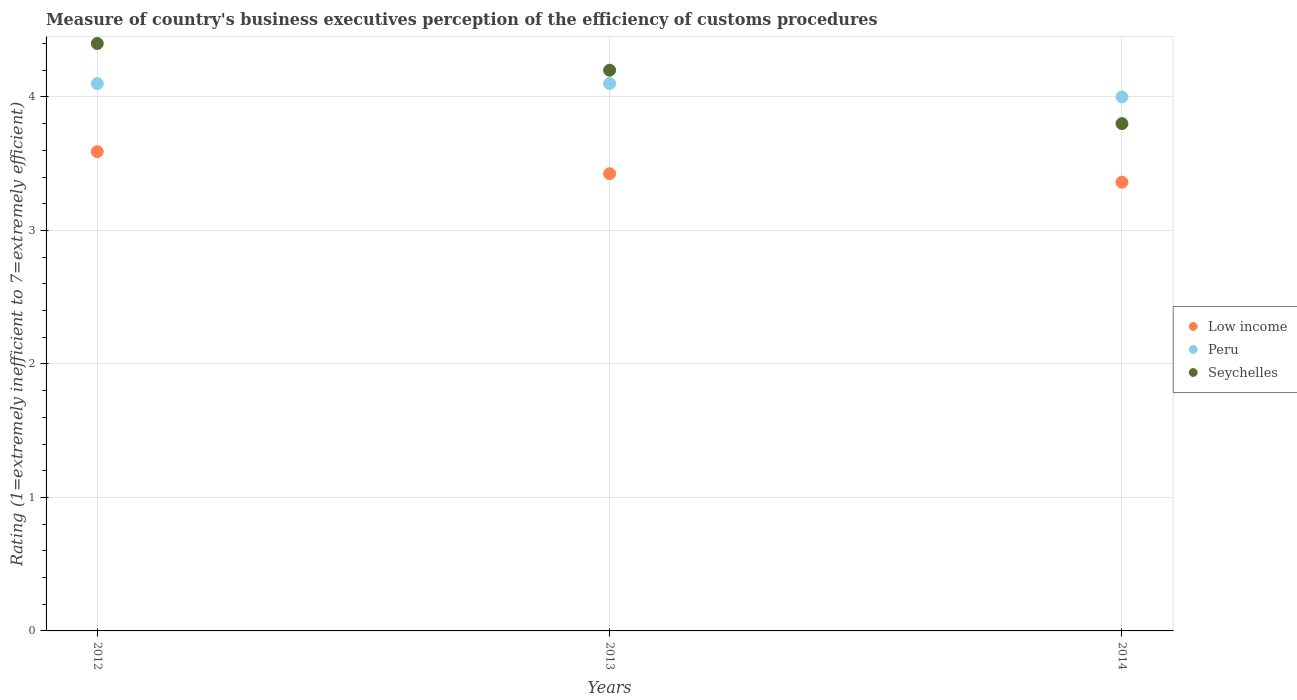How many different coloured dotlines are there?
Offer a very short reply. 3. What is the rating of the efficiency of customs procedure in Peru in 2014?
Your answer should be compact. 4. Across all years, what is the maximum rating of the efficiency of customs procedure in Low income?
Keep it short and to the point. 3.59. Across all years, what is the minimum rating of the efficiency of customs procedure in Low income?
Provide a succinct answer. 3.36. In which year was the rating of the efficiency of customs procedure in Peru maximum?
Offer a very short reply. 2012. In which year was the rating of the efficiency of customs procedure in Seychelles minimum?
Offer a terse response. 2014. What is the total rating of the efficiency of customs procedure in Low income in the graph?
Keep it short and to the point. 10.38. What is the difference between the rating of the efficiency of customs procedure in Seychelles in 2013 and that in 2014?
Your answer should be very brief. 0.4. What is the difference between the rating of the efficiency of customs procedure in Peru in 2013 and the rating of the efficiency of customs procedure in Low income in 2014?
Keep it short and to the point. 0.74. What is the average rating of the efficiency of customs procedure in Peru per year?
Your answer should be compact. 4.07. In the year 2012, what is the difference between the rating of the efficiency of customs procedure in Peru and rating of the efficiency of customs procedure in Seychelles?
Keep it short and to the point. -0.3. What is the ratio of the rating of the efficiency of customs procedure in Low income in 2012 to that in 2013?
Make the answer very short. 1.05. Is the difference between the rating of the efficiency of customs procedure in Peru in 2013 and 2014 greater than the difference between the rating of the efficiency of customs procedure in Seychelles in 2013 and 2014?
Provide a succinct answer. No. What is the difference between the highest and the second highest rating of the efficiency of customs procedure in Low income?
Offer a very short reply. 0.17. What is the difference between the highest and the lowest rating of the efficiency of customs procedure in Seychelles?
Your response must be concise. 0.6. Is the sum of the rating of the efficiency of customs procedure in Seychelles in 2013 and 2014 greater than the maximum rating of the efficiency of customs procedure in Peru across all years?
Provide a short and direct response. Yes. Is it the case that in every year, the sum of the rating of the efficiency of customs procedure in Peru and rating of the efficiency of customs procedure in Seychelles  is greater than the rating of the efficiency of customs procedure in Low income?
Provide a succinct answer. Yes. Are the values on the major ticks of Y-axis written in scientific E-notation?
Your response must be concise. No. Does the graph contain any zero values?
Offer a terse response. No. Where does the legend appear in the graph?
Offer a terse response. Center right. How are the legend labels stacked?
Provide a short and direct response. Vertical. What is the title of the graph?
Your answer should be compact. Measure of country's business executives perception of the efficiency of customs procedures. Does "Benin" appear as one of the legend labels in the graph?
Provide a short and direct response. No. What is the label or title of the Y-axis?
Your answer should be very brief. Rating (1=extremely inefficient to 7=extremely efficient). What is the Rating (1=extremely inefficient to 7=extremely efficient) in Low income in 2012?
Your response must be concise. 3.59. What is the Rating (1=extremely inefficient to 7=extremely efficient) in Low income in 2013?
Your response must be concise. 3.42. What is the Rating (1=extremely inefficient to 7=extremely efficient) of Seychelles in 2013?
Keep it short and to the point. 4.2. What is the Rating (1=extremely inefficient to 7=extremely efficient) of Low income in 2014?
Offer a very short reply. 3.36. What is the Rating (1=extremely inefficient to 7=extremely efficient) in Seychelles in 2014?
Give a very brief answer. 3.8. Across all years, what is the maximum Rating (1=extremely inefficient to 7=extremely efficient) in Low income?
Your response must be concise. 3.59. Across all years, what is the minimum Rating (1=extremely inefficient to 7=extremely efficient) in Low income?
Ensure brevity in your answer.  3.36. Across all years, what is the minimum Rating (1=extremely inefficient to 7=extremely efficient) in Seychelles?
Ensure brevity in your answer.  3.8. What is the total Rating (1=extremely inefficient to 7=extremely efficient) of Low income in the graph?
Ensure brevity in your answer.  10.38. What is the total Rating (1=extremely inefficient to 7=extremely efficient) of Peru in the graph?
Provide a short and direct response. 12.2. What is the total Rating (1=extremely inefficient to 7=extremely efficient) in Seychelles in the graph?
Provide a succinct answer. 12.4. What is the difference between the Rating (1=extremely inefficient to 7=extremely efficient) of Low income in 2012 and that in 2013?
Offer a very short reply. 0.17. What is the difference between the Rating (1=extremely inefficient to 7=extremely efficient) of Peru in 2012 and that in 2013?
Ensure brevity in your answer.  0. What is the difference between the Rating (1=extremely inefficient to 7=extremely efficient) of Seychelles in 2012 and that in 2013?
Your response must be concise. 0.2. What is the difference between the Rating (1=extremely inefficient to 7=extremely efficient) of Low income in 2012 and that in 2014?
Provide a short and direct response. 0.23. What is the difference between the Rating (1=extremely inefficient to 7=extremely efficient) of Seychelles in 2012 and that in 2014?
Make the answer very short. 0.6. What is the difference between the Rating (1=extremely inefficient to 7=extremely efficient) of Low income in 2013 and that in 2014?
Provide a succinct answer. 0.06. What is the difference between the Rating (1=extremely inefficient to 7=extremely efficient) of Peru in 2013 and that in 2014?
Keep it short and to the point. 0.1. What is the difference between the Rating (1=extremely inefficient to 7=extremely efficient) of Low income in 2012 and the Rating (1=extremely inefficient to 7=extremely efficient) of Peru in 2013?
Offer a very short reply. -0.51. What is the difference between the Rating (1=extremely inefficient to 7=extremely efficient) of Low income in 2012 and the Rating (1=extremely inefficient to 7=extremely efficient) of Seychelles in 2013?
Provide a short and direct response. -0.61. What is the difference between the Rating (1=extremely inefficient to 7=extremely efficient) of Peru in 2012 and the Rating (1=extremely inefficient to 7=extremely efficient) of Seychelles in 2013?
Ensure brevity in your answer.  -0.1. What is the difference between the Rating (1=extremely inefficient to 7=extremely efficient) of Low income in 2012 and the Rating (1=extremely inefficient to 7=extremely efficient) of Peru in 2014?
Provide a succinct answer. -0.41. What is the difference between the Rating (1=extremely inefficient to 7=extremely efficient) of Low income in 2012 and the Rating (1=extremely inefficient to 7=extremely efficient) of Seychelles in 2014?
Your answer should be compact. -0.21. What is the difference between the Rating (1=extremely inefficient to 7=extremely efficient) of Low income in 2013 and the Rating (1=extremely inefficient to 7=extremely efficient) of Peru in 2014?
Make the answer very short. -0.57. What is the difference between the Rating (1=extremely inefficient to 7=extremely efficient) of Low income in 2013 and the Rating (1=extremely inefficient to 7=extremely efficient) of Seychelles in 2014?
Offer a very short reply. -0.38. What is the average Rating (1=extremely inefficient to 7=extremely efficient) in Low income per year?
Ensure brevity in your answer.  3.46. What is the average Rating (1=extremely inefficient to 7=extremely efficient) of Peru per year?
Keep it short and to the point. 4.07. What is the average Rating (1=extremely inefficient to 7=extremely efficient) in Seychelles per year?
Your answer should be compact. 4.13. In the year 2012, what is the difference between the Rating (1=extremely inefficient to 7=extremely efficient) in Low income and Rating (1=extremely inefficient to 7=extremely efficient) in Peru?
Make the answer very short. -0.51. In the year 2012, what is the difference between the Rating (1=extremely inefficient to 7=extremely efficient) in Low income and Rating (1=extremely inefficient to 7=extremely efficient) in Seychelles?
Give a very brief answer. -0.81. In the year 2012, what is the difference between the Rating (1=extremely inefficient to 7=extremely efficient) of Peru and Rating (1=extremely inefficient to 7=extremely efficient) of Seychelles?
Your answer should be very brief. -0.3. In the year 2013, what is the difference between the Rating (1=extremely inefficient to 7=extremely efficient) of Low income and Rating (1=extremely inefficient to 7=extremely efficient) of Peru?
Ensure brevity in your answer.  -0.68. In the year 2013, what is the difference between the Rating (1=extremely inefficient to 7=extremely efficient) in Low income and Rating (1=extremely inefficient to 7=extremely efficient) in Seychelles?
Ensure brevity in your answer.  -0.78. In the year 2013, what is the difference between the Rating (1=extremely inefficient to 7=extremely efficient) in Peru and Rating (1=extremely inefficient to 7=extremely efficient) in Seychelles?
Your response must be concise. -0.1. In the year 2014, what is the difference between the Rating (1=extremely inefficient to 7=extremely efficient) in Low income and Rating (1=extremely inefficient to 7=extremely efficient) in Peru?
Make the answer very short. -0.64. In the year 2014, what is the difference between the Rating (1=extremely inefficient to 7=extremely efficient) of Low income and Rating (1=extremely inefficient to 7=extremely efficient) of Seychelles?
Make the answer very short. -0.44. In the year 2014, what is the difference between the Rating (1=extremely inefficient to 7=extremely efficient) of Peru and Rating (1=extremely inefficient to 7=extremely efficient) of Seychelles?
Ensure brevity in your answer.  0.2. What is the ratio of the Rating (1=extremely inefficient to 7=extremely efficient) of Low income in 2012 to that in 2013?
Your response must be concise. 1.05. What is the ratio of the Rating (1=extremely inefficient to 7=extremely efficient) in Seychelles in 2012 to that in 2013?
Make the answer very short. 1.05. What is the ratio of the Rating (1=extremely inefficient to 7=extremely efficient) of Low income in 2012 to that in 2014?
Provide a succinct answer. 1.07. What is the ratio of the Rating (1=extremely inefficient to 7=extremely efficient) in Peru in 2012 to that in 2014?
Your answer should be very brief. 1.02. What is the ratio of the Rating (1=extremely inefficient to 7=extremely efficient) of Seychelles in 2012 to that in 2014?
Your answer should be compact. 1.16. What is the ratio of the Rating (1=extremely inefficient to 7=extremely efficient) in Peru in 2013 to that in 2014?
Offer a very short reply. 1.02. What is the ratio of the Rating (1=extremely inefficient to 7=extremely efficient) of Seychelles in 2013 to that in 2014?
Keep it short and to the point. 1.11. What is the difference between the highest and the second highest Rating (1=extremely inefficient to 7=extremely efficient) of Low income?
Offer a very short reply. 0.17. What is the difference between the highest and the lowest Rating (1=extremely inefficient to 7=extremely efficient) in Low income?
Ensure brevity in your answer.  0.23. What is the difference between the highest and the lowest Rating (1=extremely inefficient to 7=extremely efficient) of Peru?
Ensure brevity in your answer.  0.1. 